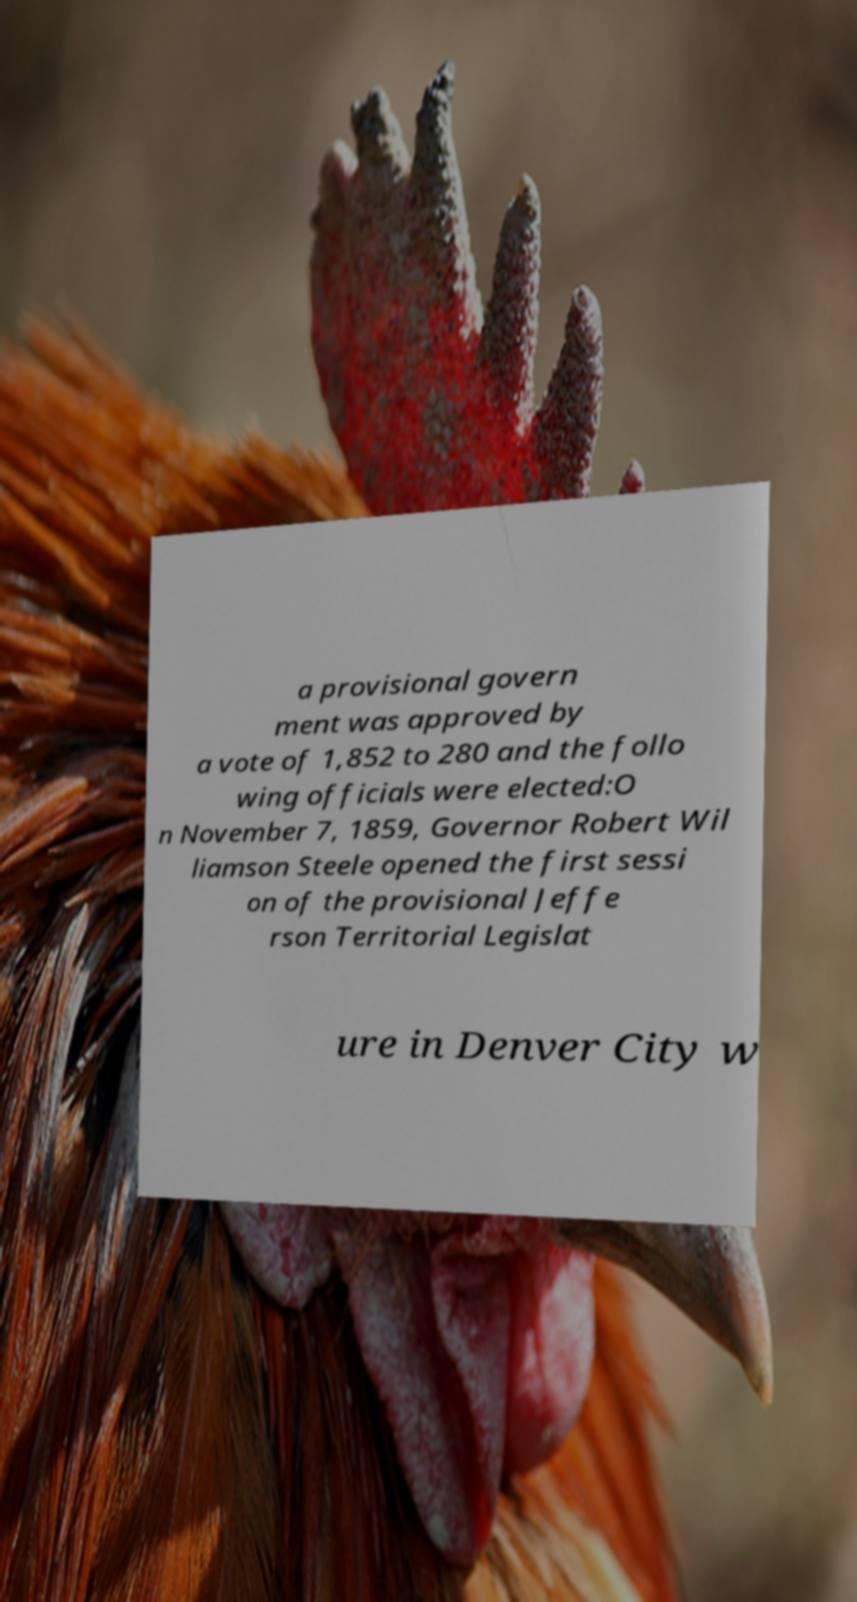I need the written content from this picture converted into text. Can you do that? a provisional govern ment was approved by a vote of 1,852 to 280 and the follo wing officials were elected:O n November 7, 1859, Governor Robert Wil liamson Steele opened the first sessi on of the provisional Jeffe rson Territorial Legislat ure in Denver City w 